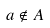<formula> <loc_0><loc_0><loc_500><loc_500>a \notin A</formula> 